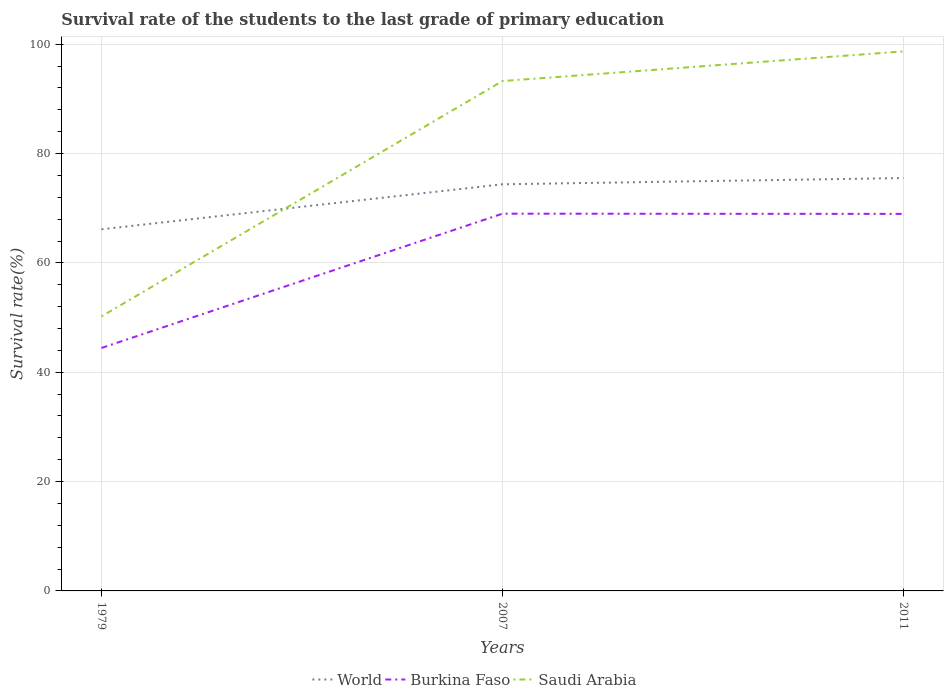How many different coloured lines are there?
Give a very brief answer. 3. Does the line corresponding to Burkina Faso intersect with the line corresponding to Saudi Arabia?
Your answer should be compact. No. Across all years, what is the maximum survival rate of the students in World?
Give a very brief answer. 66.15. In which year was the survival rate of the students in World maximum?
Ensure brevity in your answer.  1979. What is the total survival rate of the students in Saudi Arabia in the graph?
Make the answer very short. -5.42. What is the difference between the highest and the second highest survival rate of the students in World?
Provide a short and direct response. 9.37. How many lines are there?
Your response must be concise. 3. What is the difference between two consecutive major ticks on the Y-axis?
Your response must be concise. 20. Does the graph contain any zero values?
Give a very brief answer. No. What is the title of the graph?
Ensure brevity in your answer.  Survival rate of the students to the last grade of primary education. What is the label or title of the Y-axis?
Offer a terse response. Survival rate(%). What is the Survival rate(%) of World in 1979?
Your response must be concise. 66.15. What is the Survival rate(%) in Burkina Faso in 1979?
Offer a terse response. 44.44. What is the Survival rate(%) of Saudi Arabia in 1979?
Give a very brief answer. 50.22. What is the Survival rate(%) of World in 2007?
Your response must be concise. 74.38. What is the Survival rate(%) of Burkina Faso in 2007?
Give a very brief answer. 69. What is the Survival rate(%) in Saudi Arabia in 2007?
Keep it short and to the point. 93.27. What is the Survival rate(%) of World in 2011?
Provide a short and direct response. 75.52. What is the Survival rate(%) of Burkina Faso in 2011?
Ensure brevity in your answer.  68.97. What is the Survival rate(%) of Saudi Arabia in 2011?
Ensure brevity in your answer.  98.69. Across all years, what is the maximum Survival rate(%) in World?
Provide a short and direct response. 75.52. Across all years, what is the maximum Survival rate(%) of Burkina Faso?
Your answer should be compact. 69. Across all years, what is the maximum Survival rate(%) of Saudi Arabia?
Give a very brief answer. 98.69. Across all years, what is the minimum Survival rate(%) in World?
Your answer should be compact. 66.15. Across all years, what is the minimum Survival rate(%) of Burkina Faso?
Your response must be concise. 44.44. Across all years, what is the minimum Survival rate(%) in Saudi Arabia?
Provide a succinct answer. 50.22. What is the total Survival rate(%) of World in the graph?
Offer a very short reply. 216.06. What is the total Survival rate(%) of Burkina Faso in the graph?
Keep it short and to the point. 182.41. What is the total Survival rate(%) of Saudi Arabia in the graph?
Make the answer very short. 242.17. What is the difference between the Survival rate(%) of World in 1979 and that in 2007?
Keep it short and to the point. -8.23. What is the difference between the Survival rate(%) of Burkina Faso in 1979 and that in 2007?
Your response must be concise. -24.56. What is the difference between the Survival rate(%) in Saudi Arabia in 1979 and that in 2007?
Make the answer very short. -43.05. What is the difference between the Survival rate(%) in World in 1979 and that in 2011?
Make the answer very short. -9.37. What is the difference between the Survival rate(%) in Burkina Faso in 1979 and that in 2011?
Your answer should be very brief. -24.52. What is the difference between the Survival rate(%) in Saudi Arabia in 1979 and that in 2011?
Provide a succinct answer. -48.47. What is the difference between the Survival rate(%) of World in 2007 and that in 2011?
Provide a succinct answer. -1.14. What is the difference between the Survival rate(%) in Burkina Faso in 2007 and that in 2011?
Provide a short and direct response. 0.04. What is the difference between the Survival rate(%) in Saudi Arabia in 2007 and that in 2011?
Give a very brief answer. -5.42. What is the difference between the Survival rate(%) in World in 1979 and the Survival rate(%) in Burkina Faso in 2007?
Make the answer very short. -2.85. What is the difference between the Survival rate(%) of World in 1979 and the Survival rate(%) of Saudi Arabia in 2007?
Your answer should be very brief. -27.12. What is the difference between the Survival rate(%) of Burkina Faso in 1979 and the Survival rate(%) of Saudi Arabia in 2007?
Your answer should be compact. -48.82. What is the difference between the Survival rate(%) in World in 1979 and the Survival rate(%) in Burkina Faso in 2011?
Offer a terse response. -2.82. What is the difference between the Survival rate(%) in World in 1979 and the Survival rate(%) in Saudi Arabia in 2011?
Provide a succinct answer. -32.54. What is the difference between the Survival rate(%) in Burkina Faso in 1979 and the Survival rate(%) in Saudi Arabia in 2011?
Ensure brevity in your answer.  -54.25. What is the difference between the Survival rate(%) of World in 2007 and the Survival rate(%) of Burkina Faso in 2011?
Make the answer very short. 5.42. What is the difference between the Survival rate(%) of World in 2007 and the Survival rate(%) of Saudi Arabia in 2011?
Your answer should be very brief. -24.31. What is the difference between the Survival rate(%) of Burkina Faso in 2007 and the Survival rate(%) of Saudi Arabia in 2011?
Offer a terse response. -29.68. What is the average Survival rate(%) of World per year?
Your answer should be very brief. 72.02. What is the average Survival rate(%) of Burkina Faso per year?
Provide a succinct answer. 60.8. What is the average Survival rate(%) in Saudi Arabia per year?
Your response must be concise. 80.72. In the year 1979, what is the difference between the Survival rate(%) of World and Survival rate(%) of Burkina Faso?
Your response must be concise. 21.71. In the year 1979, what is the difference between the Survival rate(%) in World and Survival rate(%) in Saudi Arabia?
Your response must be concise. 15.93. In the year 1979, what is the difference between the Survival rate(%) of Burkina Faso and Survival rate(%) of Saudi Arabia?
Make the answer very short. -5.78. In the year 2007, what is the difference between the Survival rate(%) of World and Survival rate(%) of Burkina Faso?
Offer a terse response. 5.38. In the year 2007, what is the difference between the Survival rate(%) in World and Survival rate(%) in Saudi Arabia?
Ensure brevity in your answer.  -18.88. In the year 2007, what is the difference between the Survival rate(%) in Burkina Faso and Survival rate(%) in Saudi Arabia?
Your answer should be very brief. -24.26. In the year 2011, what is the difference between the Survival rate(%) in World and Survival rate(%) in Burkina Faso?
Offer a very short reply. 6.56. In the year 2011, what is the difference between the Survival rate(%) of World and Survival rate(%) of Saudi Arabia?
Ensure brevity in your answer.  -23.16. In the year 2011, what is the difference between the Survival rate(%) in Burkina Faso and Survival rate(%) in Saudi Arabia?
Your answer should be very brief. -29.72. What is the ratio of the Survival rate(%) in World in 1979 to that in 2007?
Offer a terse response. 0.89. What is the ratio of the Survival rate(%) of Burkina Faso in 1979 to that in 2007?
Make the answer very short. 0.64. What is the ratio of the Survival rate(%) in Saudi Arabia in 1979 to that in 2007?
Ensure brevity in your answer.  0.54. What is the ratio of the Survival rate(%) of World in 1979 to that in 2011?
Your response must be concise. 0.88. What is the ratio of the Survival rate(%) of Burkina Faso in 1979 to that in 2011?
Ensure brevity in your answer.  0.64. What is the ratio of the Survival rate(%) in Saudi Arabia in 1979 to that in 2011?
Provide a succinct answer. 0.51. What is the ratio of the Survival rate(%) of World in 2007 to that in 2011?
Give a very brief answer. 0.98. What is the ratio of the Survival rate(%) of Burkina Faso in 2007 to that in 2011?
Provide a short and direct response. 1. What is the ratio of the Survival rate(%) in Saudi Arabia in 2007 to that in 2011?
Ensure brevity in your answer.  0.95. What is the difference between the highest and the second highest Survival rate(%) in World?
Provide a short and direct response. 1.14. What is the difference between the highest and the second highest Survival rate(%) in Burkina Faso?
Keep it short and to the point. 0.04. What is the difference between the highest and the second highest Survival rate(%) of Saudi Arabia?
Give a very brief answer. 5.42. What is the difference between the highest and the lowest Survival rate(%) in World?
Give a very brief answer. 9.37. What is the difference between the highest and the lowest Survival rate(%) in Burkina Faso?
Your answer should be compact. 24.56. What is the difference between the highest and the lowest Survival rate(%) of Saudi Arabia?
Your answer should be very brief. 48.47. 